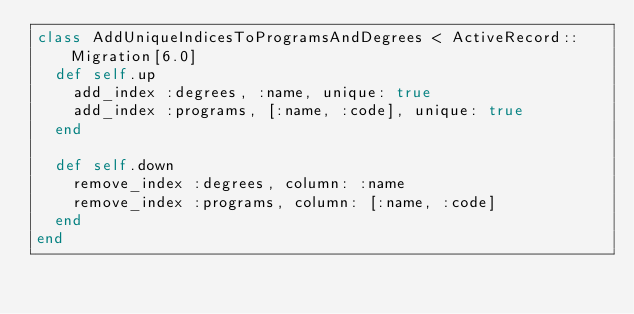Convert code to text. <code><loc_0><loc_0><loc_500><loc_500><_Ruby_>class AddUniqueIndicesToProgramsAndDegrees < ActiveRecord::Migration[6.0]
  def self.up
    add_index :degrees, :name, unique: true
    add_index :programs, [:name, :code], unique: true
  end

  def self.down
    remove_index :degrees, column: :name
    remove_index :programs, column: [:name, :code]
  end
end
</code> 